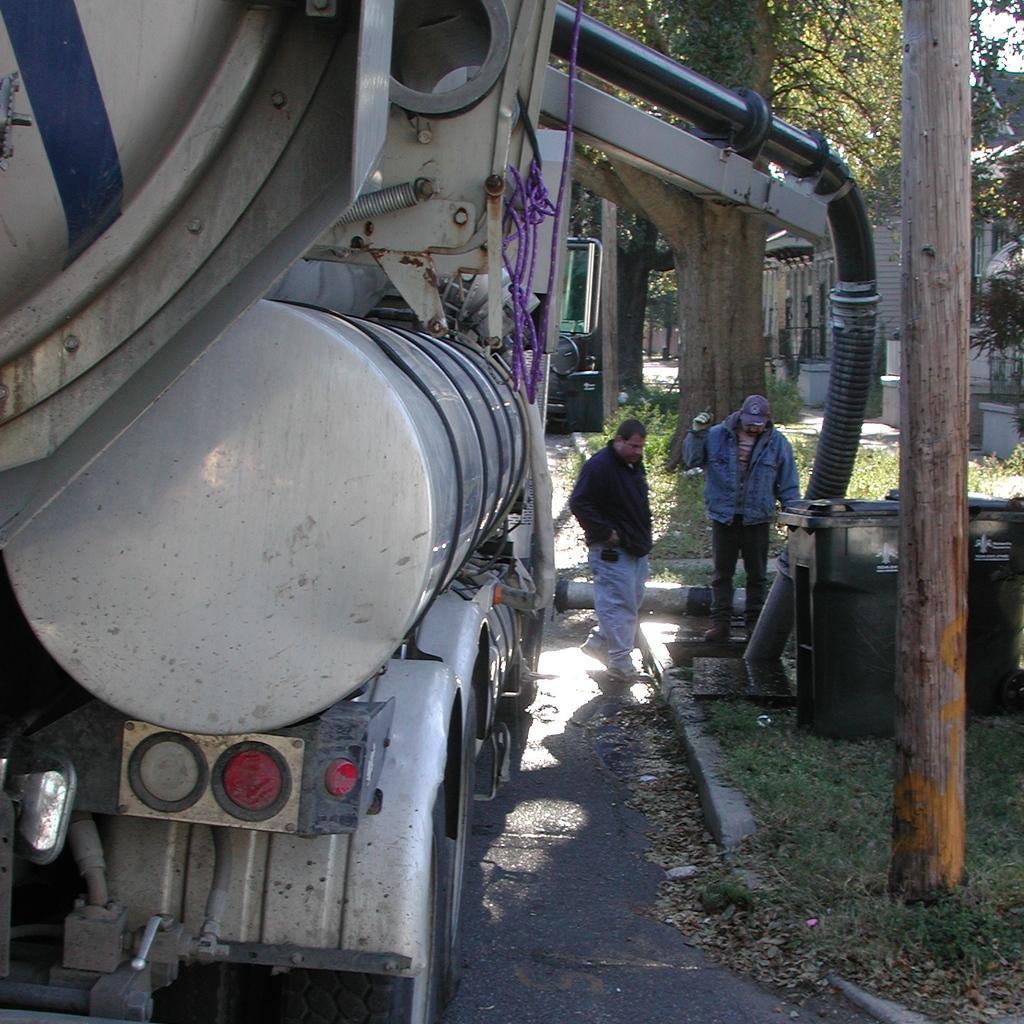Please provide a concise description of this image. In this picture we can see two people standing. We can see dustbins, trees, dry leaves and some grass on the ground. There is a house, a vehicle and other objects. 